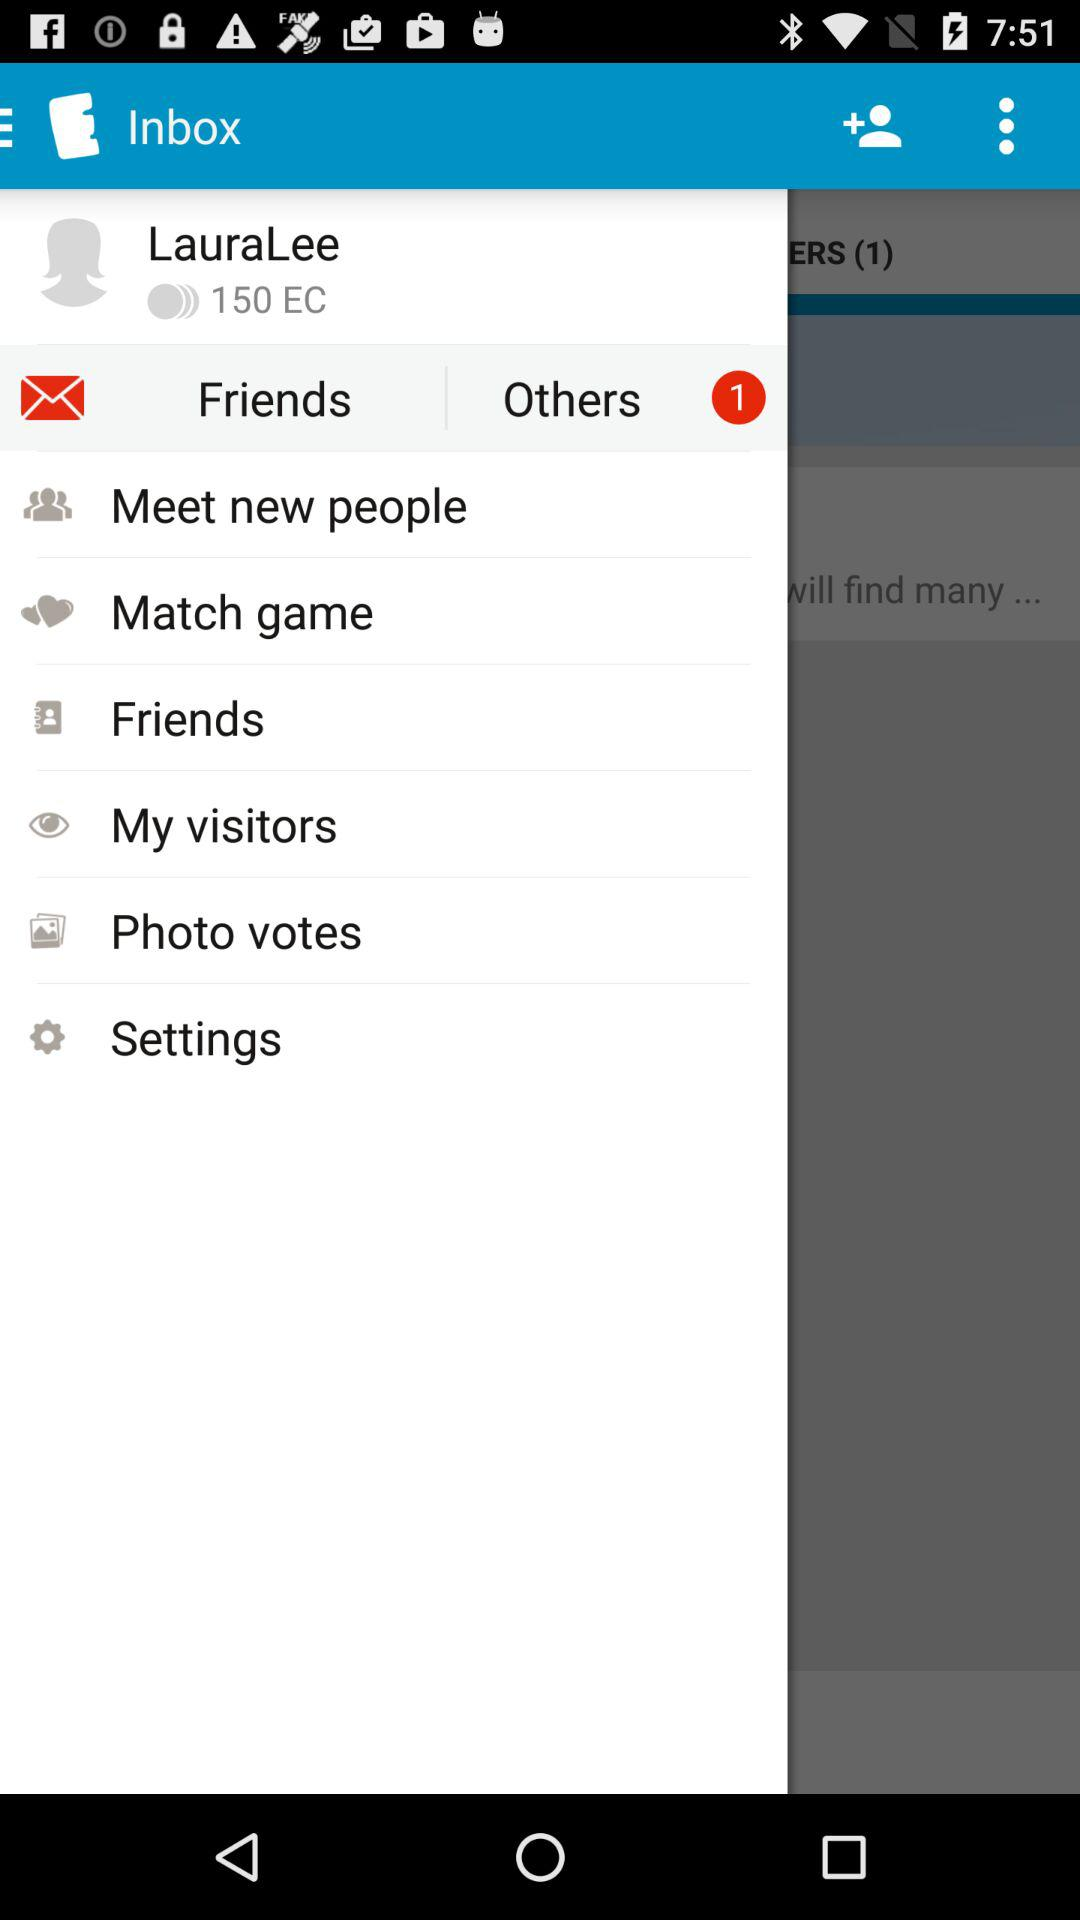How many more friends does LauraLee have than Others?
Answer the question using a single word or phrase. 1 